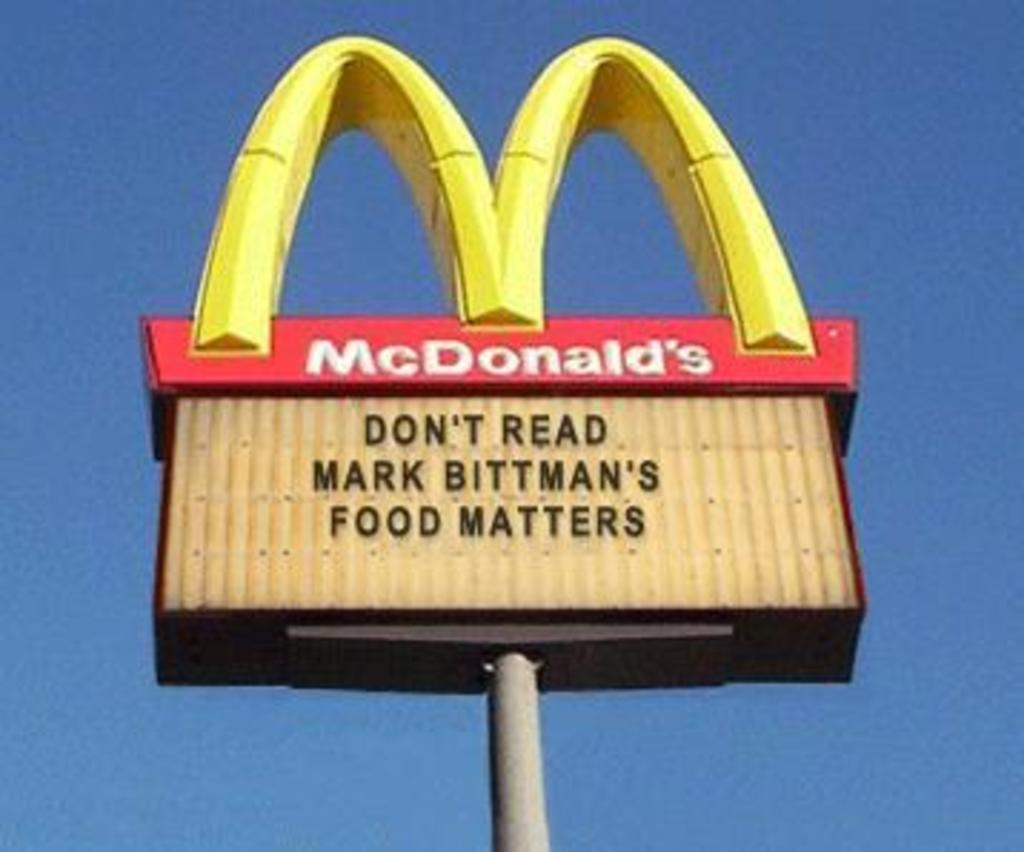<image>
Present a compact description of the photo's key features. A McDonald's sign that says Don't Read Mark Bittman's Food Matters. 